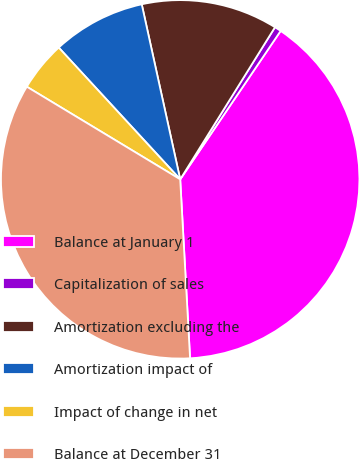Convert chart to OTSL. <chart><loc_0><loc_0><loc_500><loc_500><pie_chart><fcel>Balance at January 1<fcel>Capitalization of sales<fcel>Amortization excluding the<fcel>Amortization impact of<fcel>Impact of change in net<fcel>Balance at December 31<nl><fcel>39.65%<fcel>0.6%<fcel>12.31%<fcel>8.41%<fcel>4.5%<fcel>34.52%<nl></chart> 